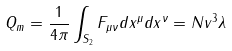Convert formula to latex. <formula><loc_0><loc_0><loc_500><loc_500>Q _ { m } = \frac { 1 } { 4 \pi } \int _ { S _ { 2 } } F _ { \mu \nu } d x ^ { \mu } d x ^ { \nu } = N v ^ { 3 } \lambda</formula> 